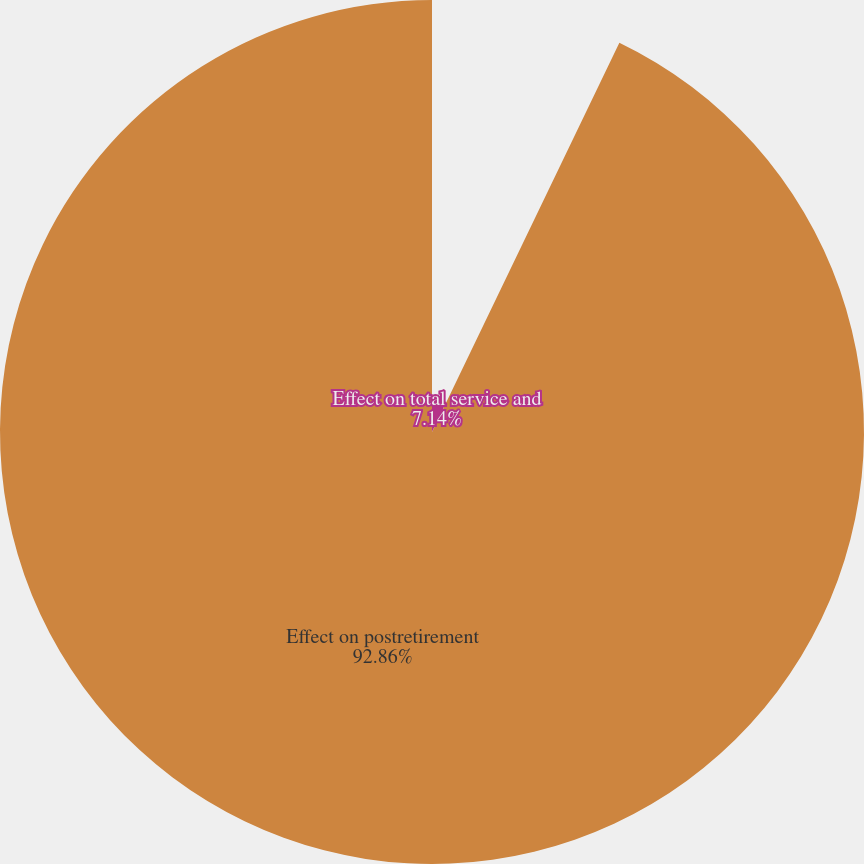Convert chart. <chart><loc_0><loc_0><loc_500><loc_500><pie_chart><fcel>Effect on total service and<fcel>Effect on postretirement<nl><fcel>7.14%<fcel>92.86%<nl></chart> 